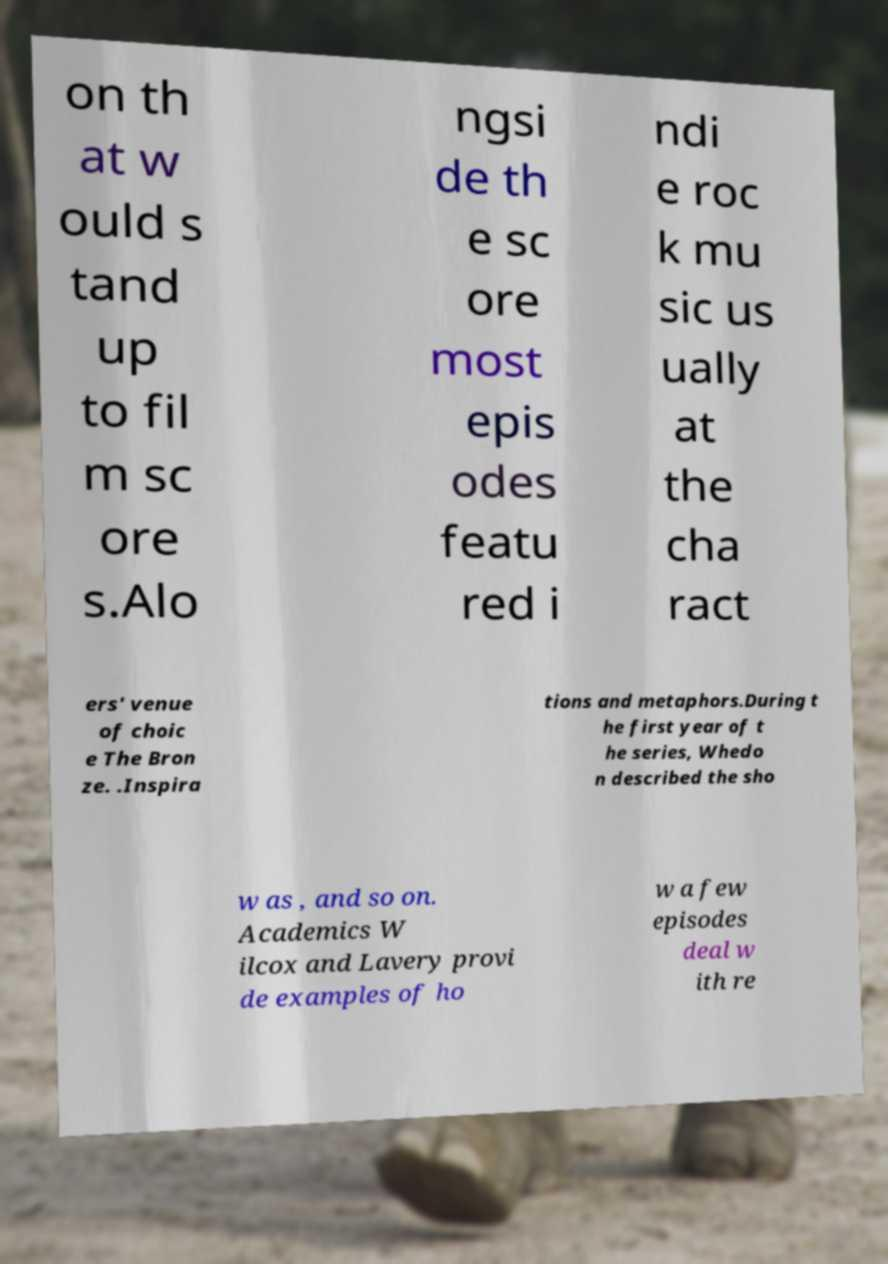Can you accurately transcribe the text from the provided image for me? on th at w ould s tand up to fil m sc ore s.Alo ngsi de th e sc ore most epis odes featu red i ndi e roc k mu sic us ually at the cha ract ers' venue of choic e The Bron ze. .Inspira tions and metaphors.During t he first year of t he series, Whedo n described the sho w as , and so on. Academics W ilcox and Lavery provi de examples of ho w a few episodes deal w ith re 